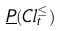<formula> <loc_0><loc_0><loc_500><loc_500>\underline { P } ( C l _ { t } ^ { \leq } )</formula> 